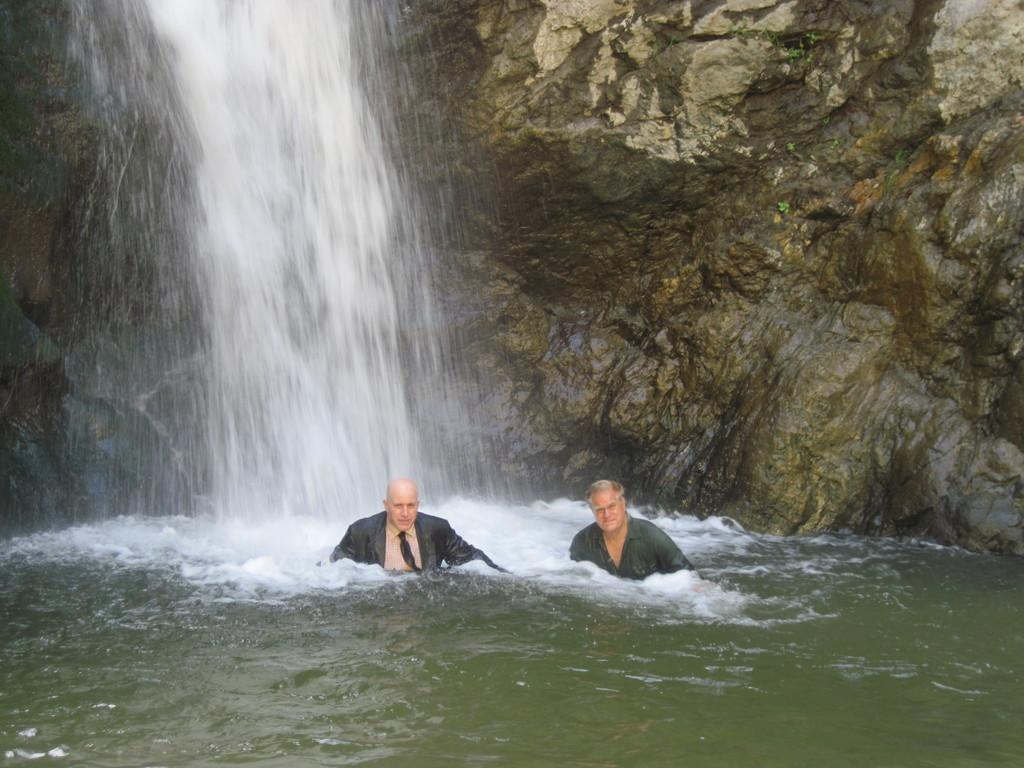What natural feature is the main subject of the image? There is a waterfall in the image. What are the two persons in the image doing? The two persons are in the water. What can be seen in the background of the image? There are rocks visible in the background of the image. How many earths can be seen in the image? There is no reference to the planet Earth in the image, so it is not possible to determine how many earths might be visible. 